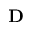<formula> <loc_0><loc_0><loc_500><loc_500>D</formula> 